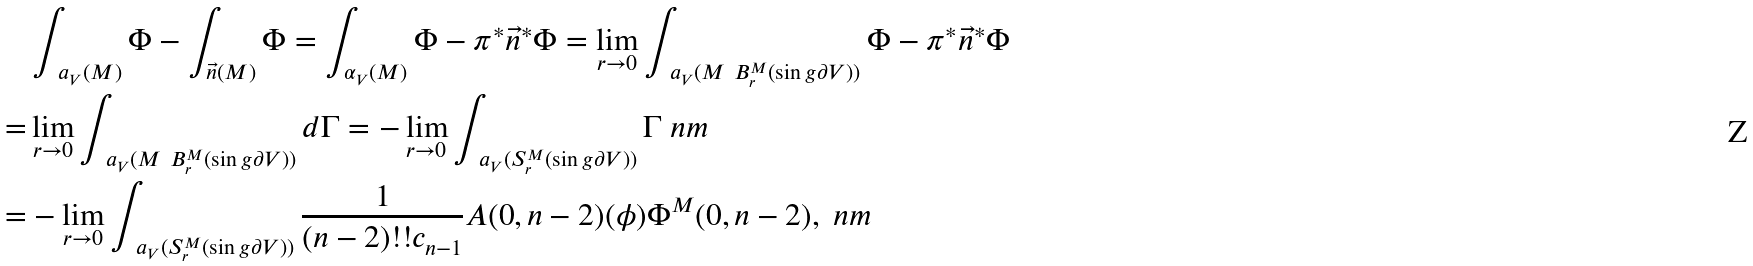<formula> <loc_0><loc_0><loc_500><loc_500>& \int _ { \ a _ { V } ( M ) } \Phi - \int _ { \vec { n } ( M ) } \Phi = \int _ { \alpha _ { V } ( M ) } \Phi - \pi ^ { * } \vec { n } ^ { * } \Phi = \lim _ { r \to 0 } \int _ { \ a _ { V } ( M \ B _ { r } ^ { M } ( \sin g \partial V ) ) } \Phi - \pi ^ { * } \vec { n } ^ { * } \Phi \\ = & \lim _ { r \to 0 } \int _ { \ a _ { V } ( M \ B _ { r } ^ { M } ( \sin g \partial V ) ) } d \Gamma = - \lim _ { r \to 0 } \int _ { \ a _ { V } ( S _ { r } ^ { M } ( \sin g \partial V ) ) } \Gamma \ n m \\ = & - \lim _ { r \to 0 } \int _ { \ a _ { V } ( S _ { r } ^ { M } ( \sin g \partial V ) ) } \frac { 1 } { ( n - 2 ) ! ! c _ { n - 1 } } A ( 0 , n - 2 ) ( \phi ) \Phi ^ { M } ( 0 , n - 2 ) , \ n m</formula> 